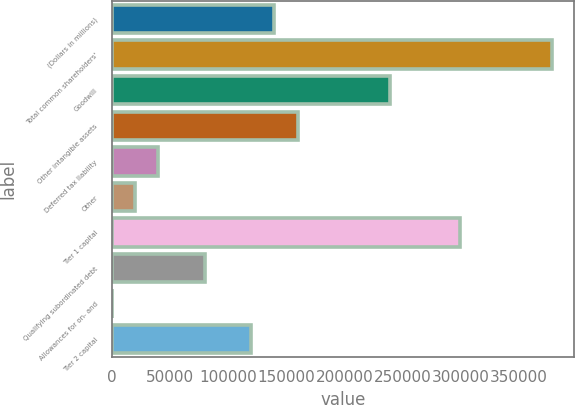Convert chart to OTSL. <chart><loc_0><loc_0><loc_500><loc_500><bar_chart><fcel>(Dollars in millions)<fcel>Total common shareholders'<fcel>Goodwill<fcel>Other intangible assets<fcel>Deferred tax liability<fcel>Other<fcel>Tier 1 capital<fcel>Qualifying subordinated debt<fcel>Allowances for on- and<fcel>Tier 2 capital<nl><fcel>139524<fcel>378631<fcel>239152<fcel>159450<fcel>39896.2<fcel>19970.6<fcel>298929<fcel>79747.4<fcel>45<fcel>119599<nl></chart> 